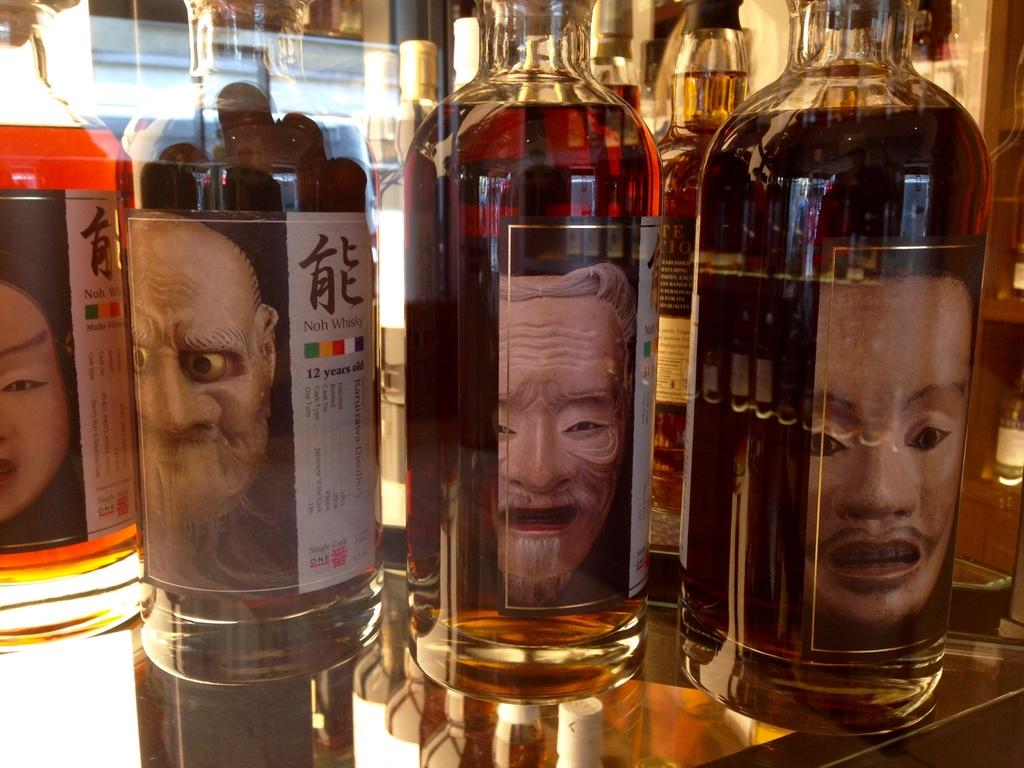Where was the image taken? The image was taken inside a room. What type of table is visible in the image? There is a glass table in the image. What can be found on the table? There are bottles with wine on the table. What kind of poster is present in the image? There is a labeled face shape poster in the image. What color is the pear on the dress in the image? There is no pear or dress present in the image. 